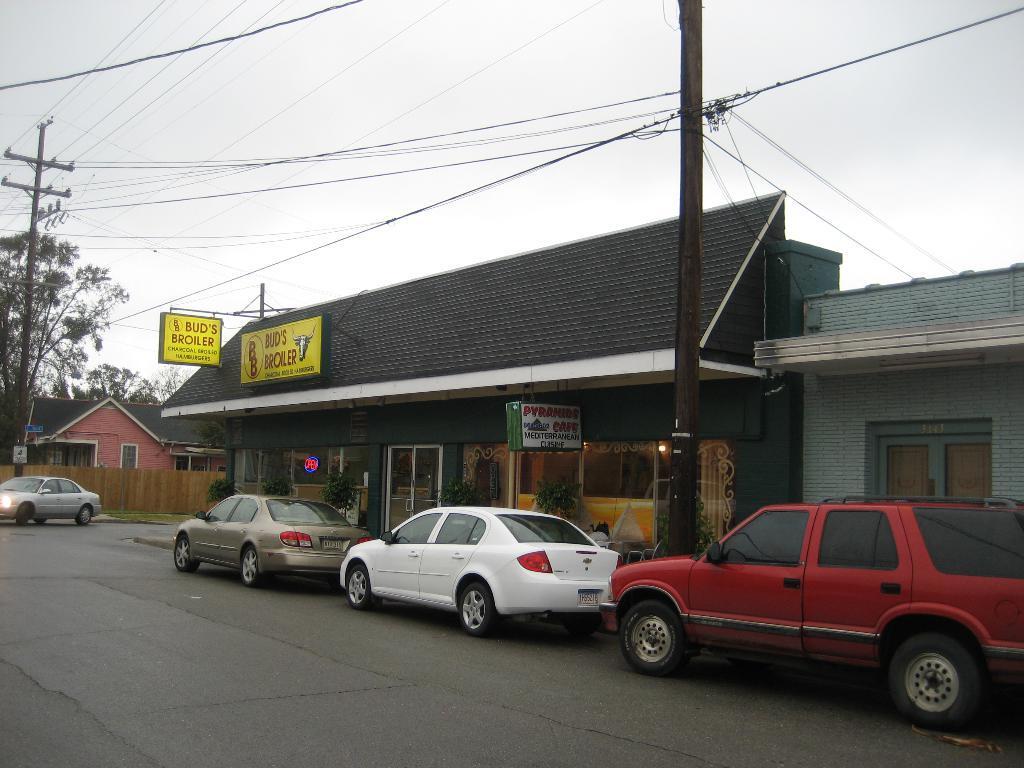Describe this image in one or two sentences. In the foreground of this image, there is a road and few vehicles are placed side to a road. In the middle, there are few buildings, a pole, windows, few boards and cables. At the top, there is the sky. In the background, there is a house, a vehicle moving on the road, pole and few trees. 